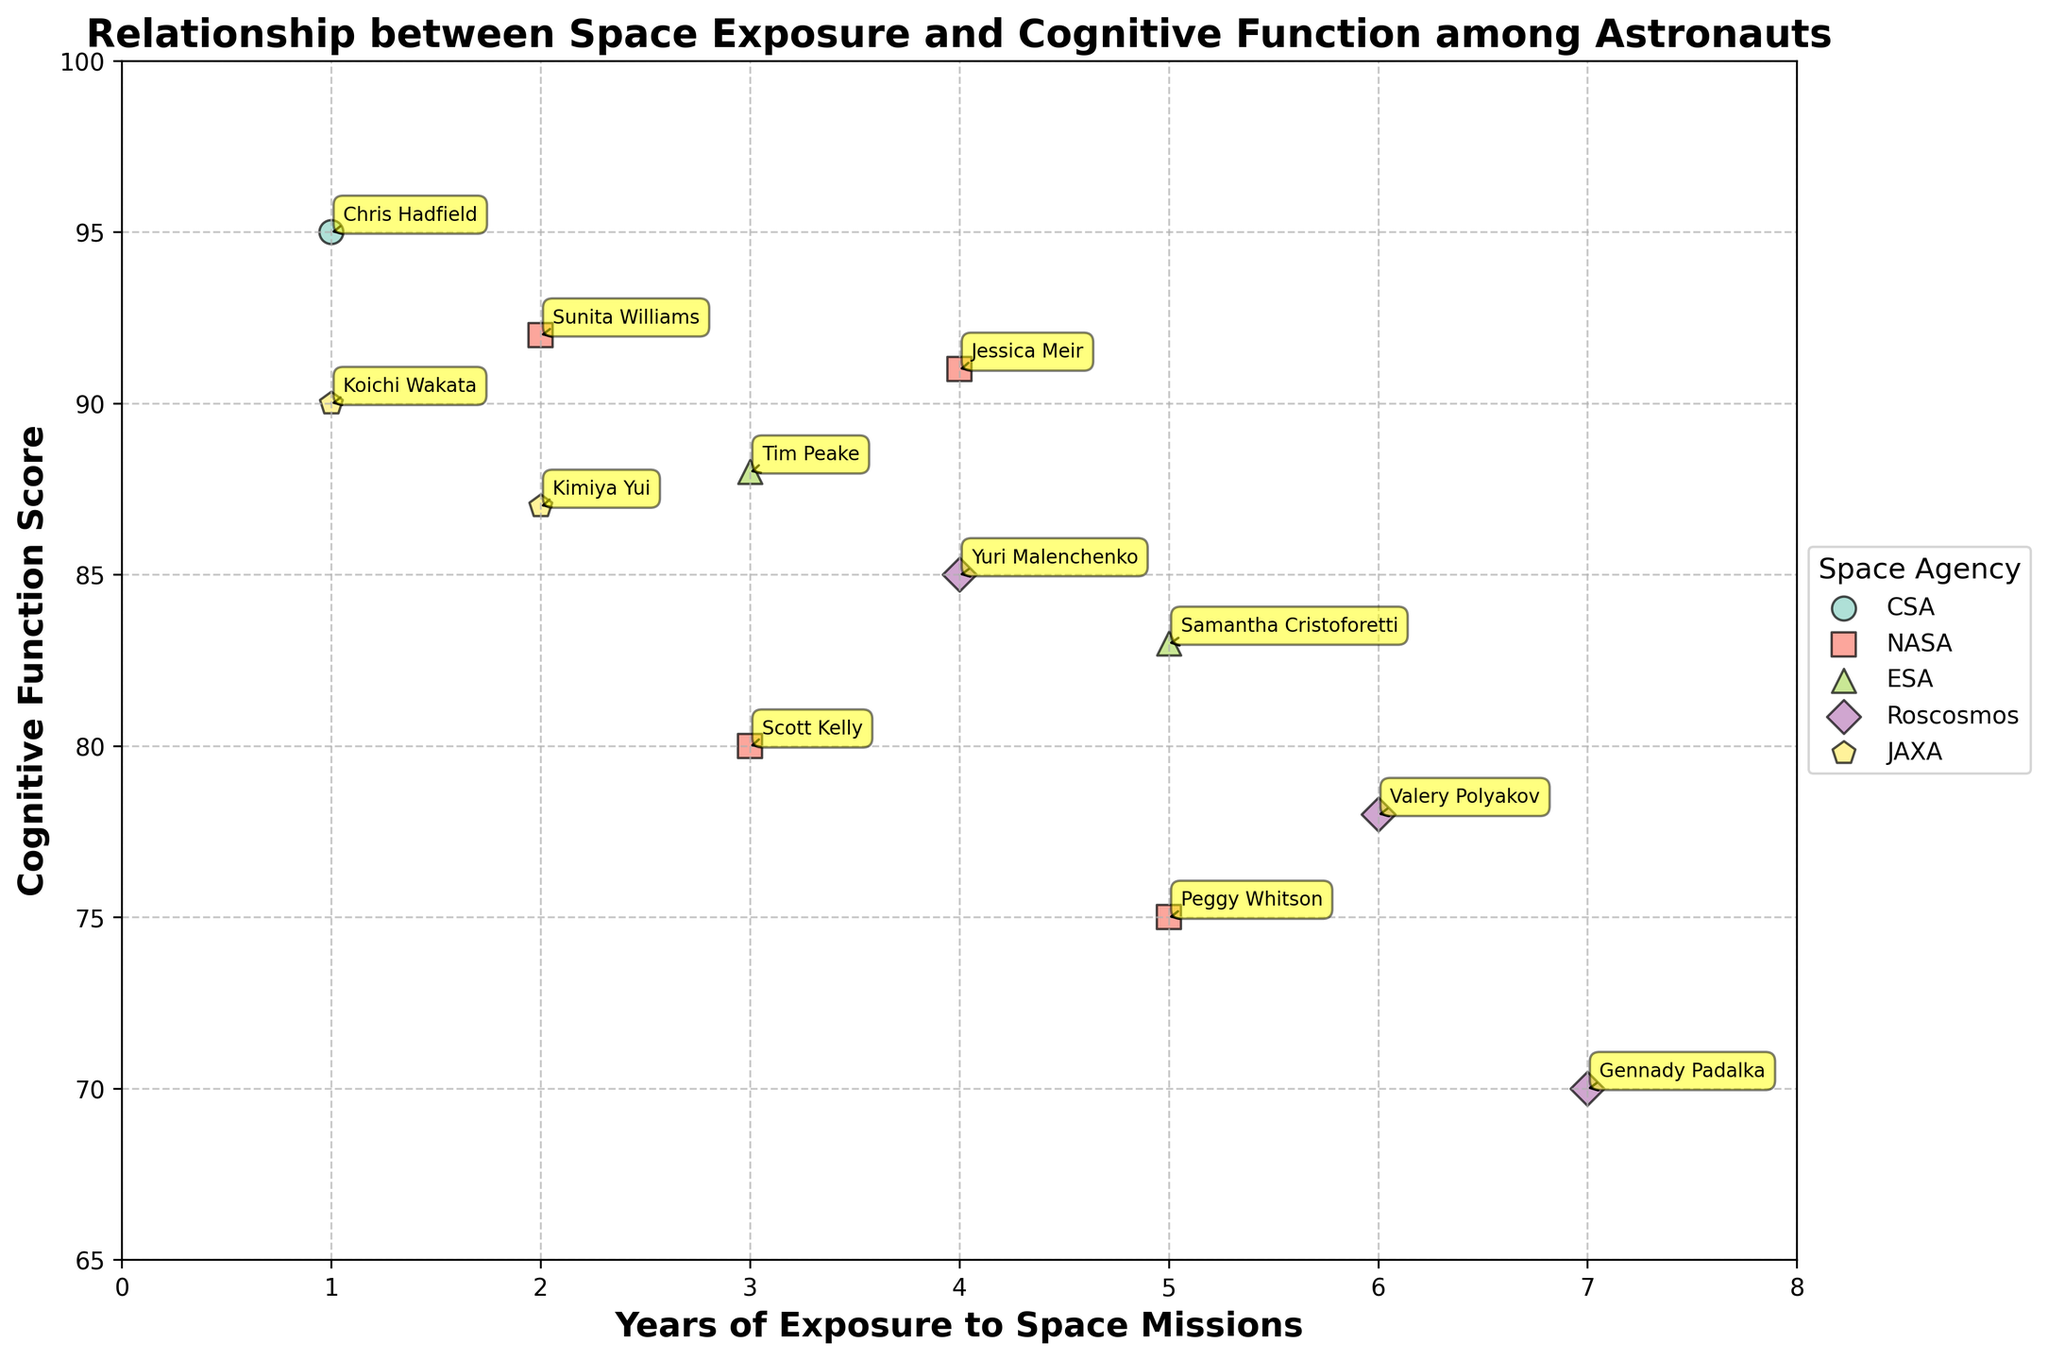What is the title of the figure? The title is usually located at the top of the plot and summarizes the main subject.
Answer: Relationship between Space Exposure and Cognitive Function among Astronauts How many astronauts from NASA are displayed in the figure? Identify and count the unique data points labeled with 'NASA'.
Answer: 4 Which astronaut has the highest cognitive function score, and what is that score? Look for the data point with the highest y-axis value and note the label and value.
Answer: Chris Hadfield, 95 What is the cognitive function score for Yuri Malenchenko? Find the label 'Yuri Malenchenko' and read the corresponding y-axis value.
Answer: 85 What is the average cognitive function score of astronauts from ESA? Sum the cognitive function scores of the astronauts from ESA and divide by the number of ESA astronauts. Samantha Cristoforetti and Tim Peake have scores of 83 and 88, respectively. (83 + 88) / 2 = 85.5
Answer: 85.5 Which space agency has the widest range of years of exposure in the plot? Compare the range of years of exposure for each space agency by looking at the spread of data points along the x-axis. Roscosmos ranges from 4 to 7 years.
Answer: Roscosmos How does Scott Kelly's cognitive function score compare to that of Peggy Whitson? Compare the y-axis values of Scott Kelly and Peggy Whitson. Scott Kelly has a score of 80, while Peggy Whitson has a score of 75.
Answer: Scott Kelly's score is higher What trend, if any, can be observed between years of exposure and cognitive function score? Look for patterns or correlations between the x-axis and y-axis data points.
Answer: Higher years of exposure generally correlate with lower cognitive function scores Which astronaut has the maximum years of exposure, and what is their cognitive function score? Identify the data point with the highest x-axis value and note the corresponding y-axis value and label. Gennady Padalka has 7 years of exposure and a cognitive function score of 70.
Answer: Gennady Padalka, 70 Are there any space agencies that have astronauts with years of exposure below 3 years? If so, which ones? Identify the data points with years of exposure below 3 and note their space agencies. CSA, NASA, JAXA
Answer: CSA, NASA, JAXA 